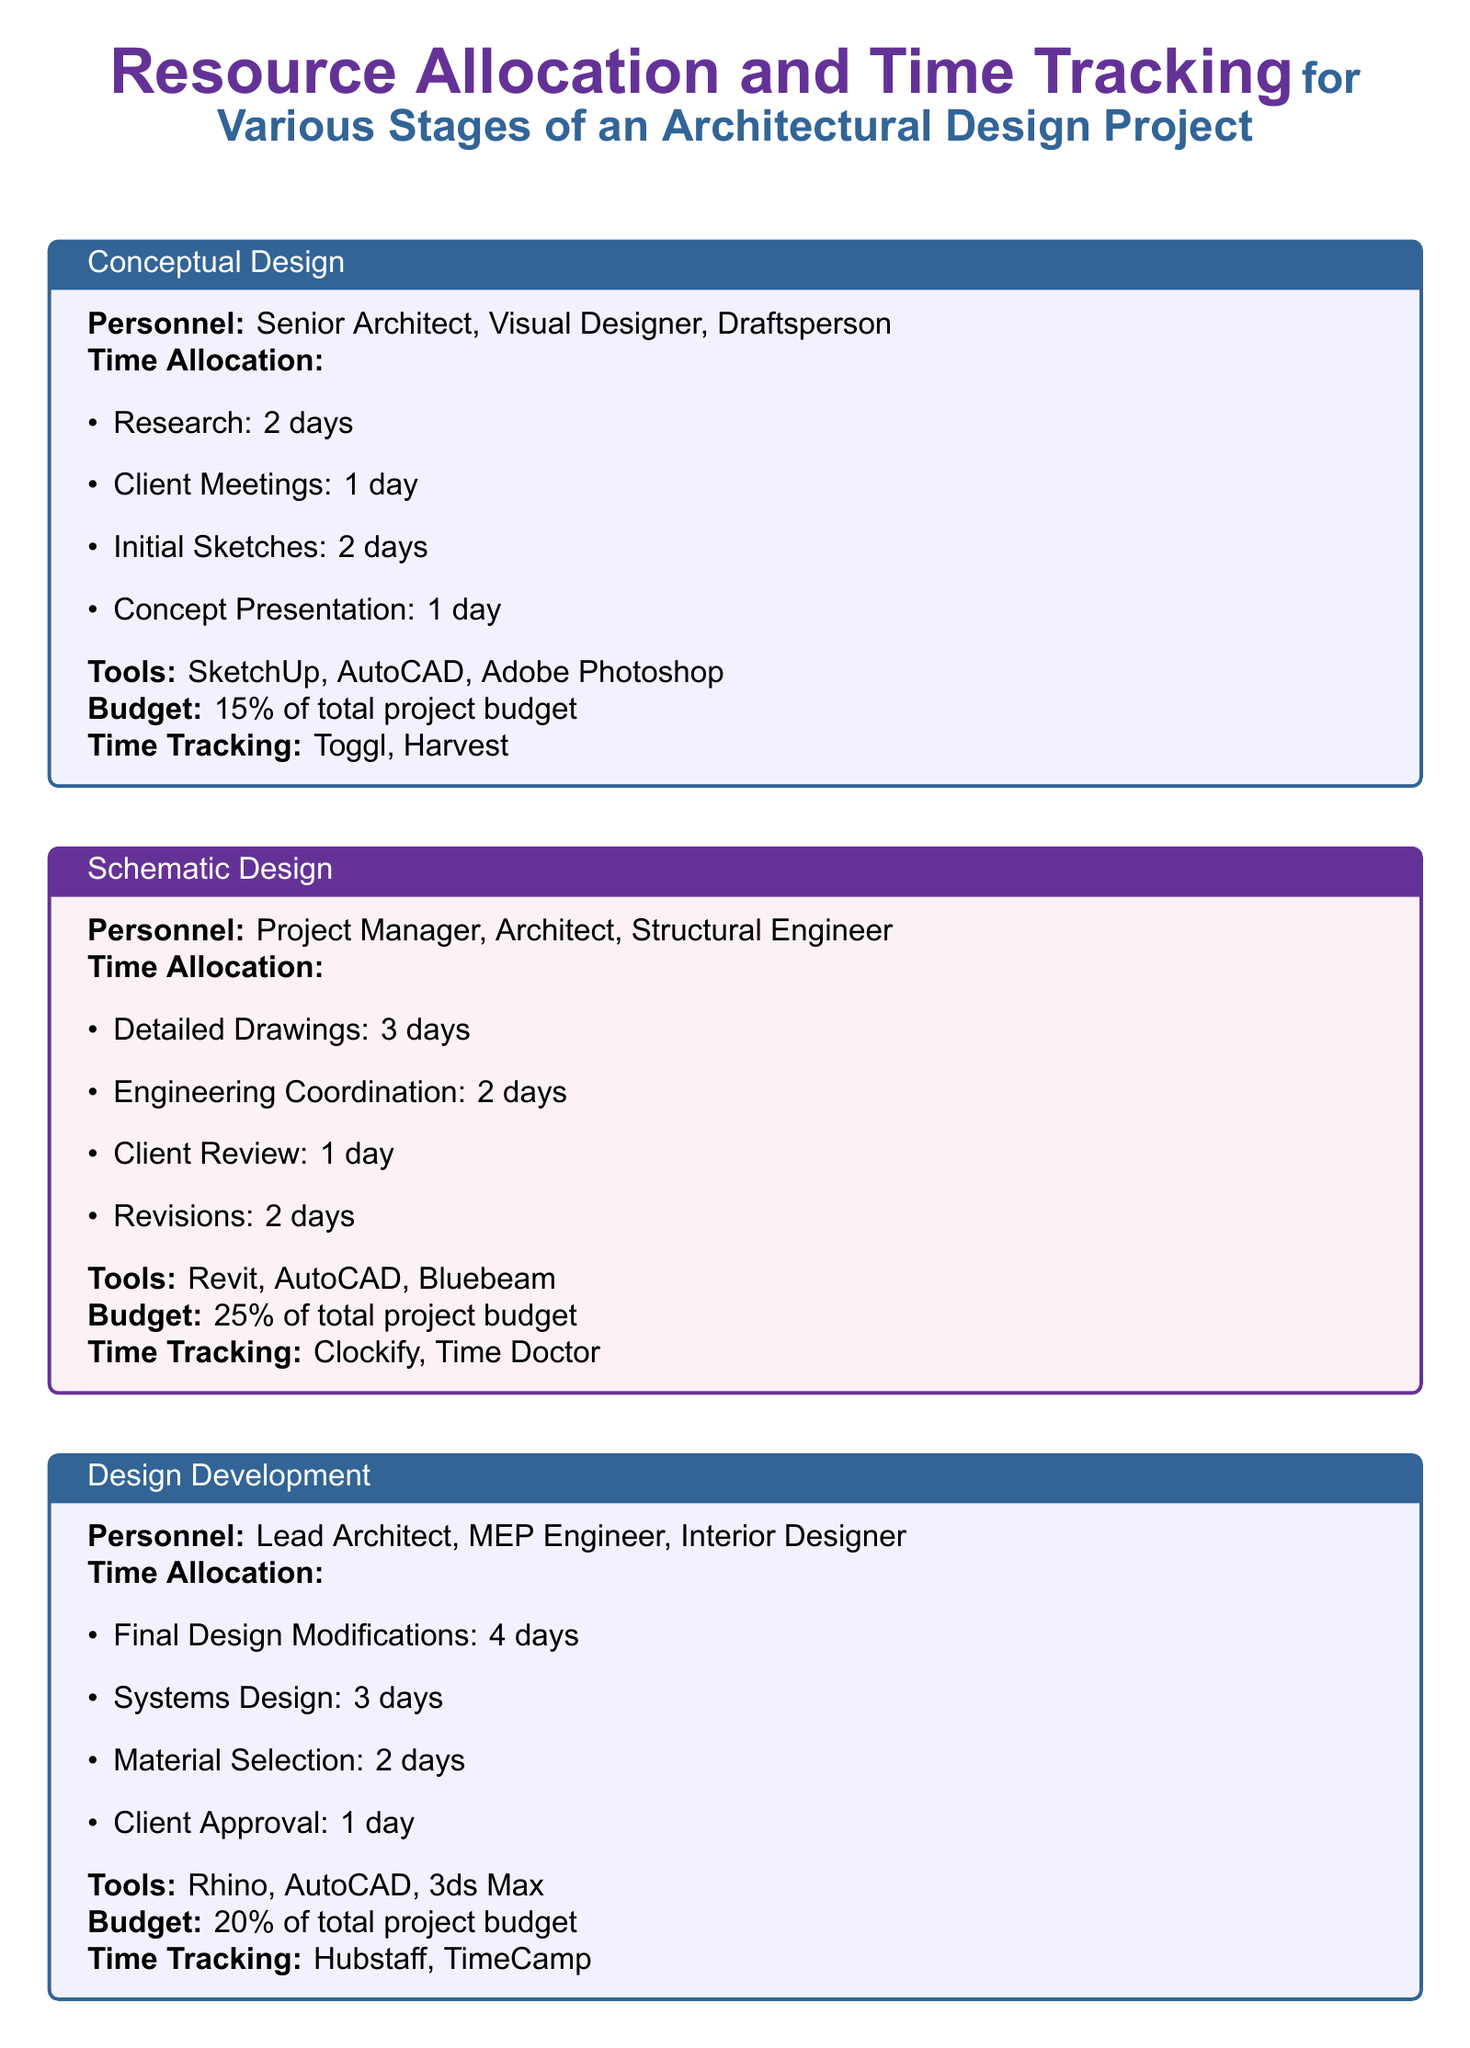What is the budget allocation for the Design Development stage? The budget allocation is stated as a percentage of the total project budget in the document. For the Design Development stage, it is 20%.
Answer: 20% How many days are allocated for client meetings in the Conceptual Design stage? The number of days for each task in this stage is listed under Time Allocation. Client meetings are allocated 1 day.
Answer: 1 day What tools are used in the Schematic Design stage? The tools used in each stage are specified in the Tools section. The Schematic Design stage uses Revit, AutoCAD, and Bluebeam.
Answer: Revit, AutoCAD, Bluebeam Who is responsible for site visits in the Construction Administration stage? Personnel responsible for each task are outlined in the Personnel section. The site supervisor is responsible for site visits.
Answer: Site Supervisor What is the total time allocation for the Construction Documentation stage? The total time allocation can be calculated by adding the time allocated for all tasks in the Construction Documentation stage. The total is 10 days (5 + 3 + 2).
Answer: 10 days Which time tracking tools are utilized in the Design Development stage? The document specifies the time tracking tools for each stage. The Design Development stage uses Hubstaff and TimeCamp.
Answer: Hubstaff, TimeCamp How many days are allocated for construction drawings in the Construction Documentation stage? Construction drawings are one of the tasks listed under Time Allocation, and they are allocated 5 days.
Answer: 5 days What is the time allocated for issue resolution in the Construction Administration stage? The time allocation for this task is clearly defined in the Time Allocation section. Issue resolution is allocated 3 days.
Answer: 3 days 